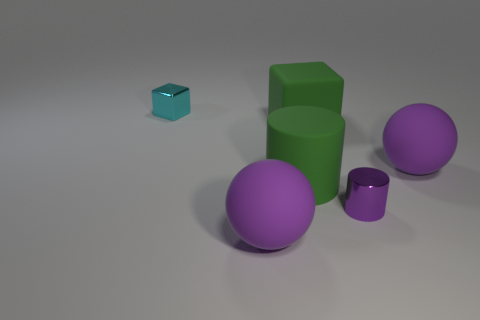Does the big purple sphere in front of the purple shiny cylinder have the same material as the tiny thing in front of the cyan object?
Provide a short and direct response. No. There is a large sphere that is on the left side of the tiny object in front of the cyan thing; are there any shiny things that are on the right side of it?
Offer a terse response. Yes. How many big things are green matte things or purple metal objects?
Ensure brevity in your answer.  2. The cube that is the same size as the purple cylinder is what color?
Your answer should be very brief. Cyan. There is a large green matte cylinder; what number of metal things are behind it?
Provide a succinct answer. 1. Are there any blocks made of the same material as the small purple object?
Give a very brief answer. Yes. What is the shape of the rubber thing that is the same color as the big rubber block?
Ensure brevity in your answer.  Cylinder. What color is the small object that is in front of the tiny metal block?
Your answer should be compact. Purple. Are there an equal number of large purple objects that are in front of the cyan metallic cube and purple matte spheres on the right side of the rubber block?
Your answer should be very brief. No. What material is the purple sphere in front of the big thing on the right side of the purple shiny cylinder?
Provide a succinct answer. Rubber. 